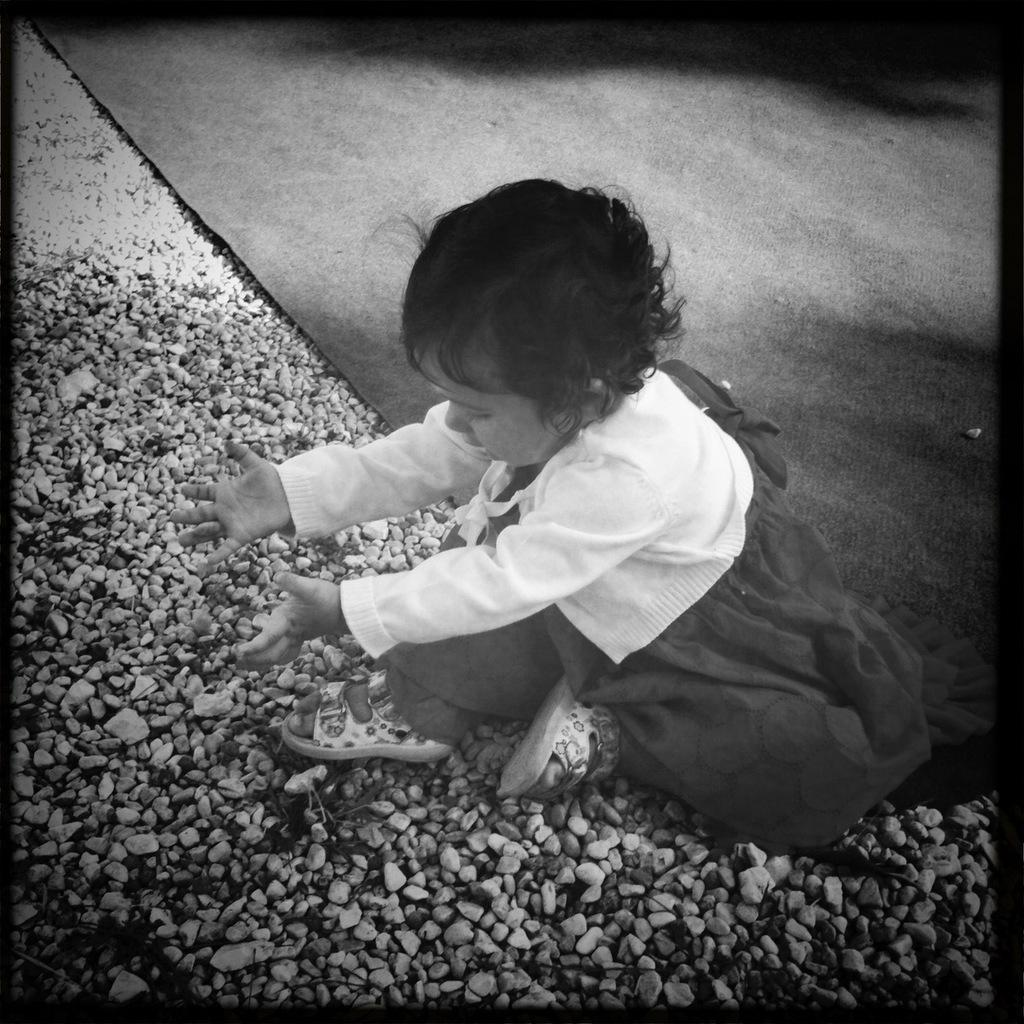What is the color scheme of the image? The image is black and white. What type of objects can be seen in the image? There are stones in the image. Who or what is in the middle of the image? There is a kid in the middle of the image. What is the kid wearing? The kid is wearing clothes. What type of gun is the kid holding in the image? There is no gun present in the image; the kid is not holding any weapon. What type of knife can be seen in the image? There is no knife present in the image; the image only features stones and a kid. 